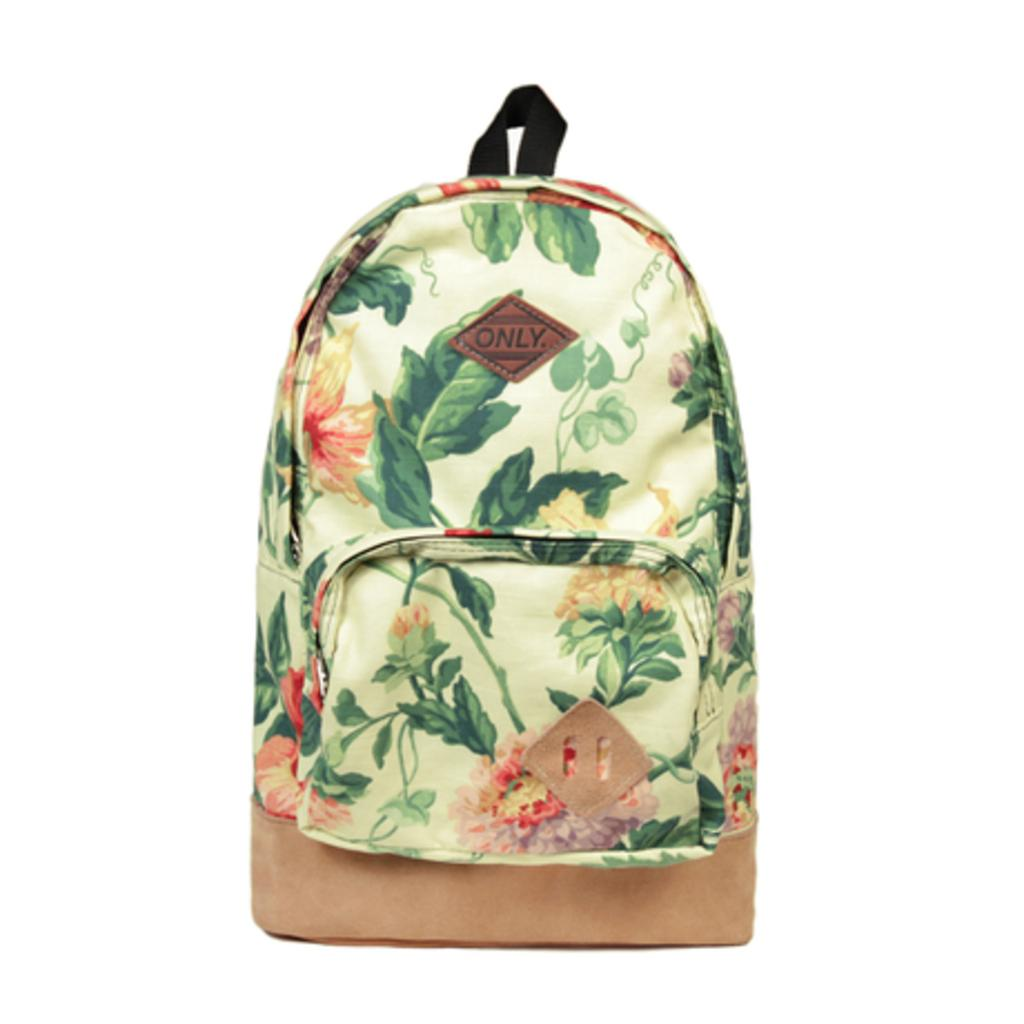<image>
Relay a brief, clear account of the picture shown. A back pack that says only on the tag also has flowers on it. 